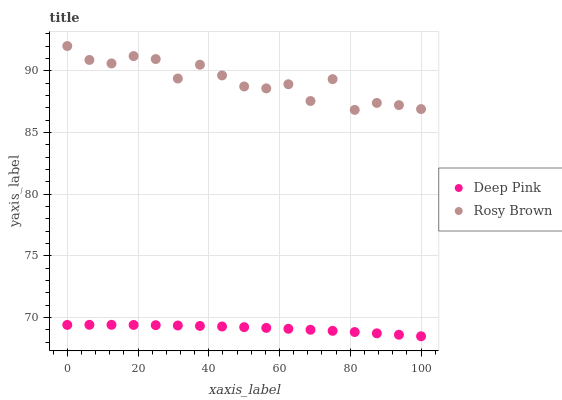Does Deep Pink have the minimum area under the curve?
Answer yes or no. Yes. Does Rosy Brown have the maximum area under the curve?
Answer yes or no. Yes. Does Deep Pink have the maximum area under the curve?
Answer yes or no. No. Is Deep Pink the smoothest?
Answer yes or no. Yes. Is Rosy Brown the roughest?
Answer yes or no. Yes. Is Deep Pink the roughest?
Answer yes or no. No. Does Deep Pink have the lowest value?
Answer yes or no. Yes. Does Rosy Brown have the highest value?
Answer yes or no. Yes. Does Deep Pink have the highest value?
Answer yes or no. No. Is Deep Pink less than Rosy Brown?
Answer yes or no. Yes. Is Rosy Brown greater than Deep Pink?
Answer yes or no. Yes. Does Deep Pink intersect Rosy Brown?
Answer yes or no. No. 